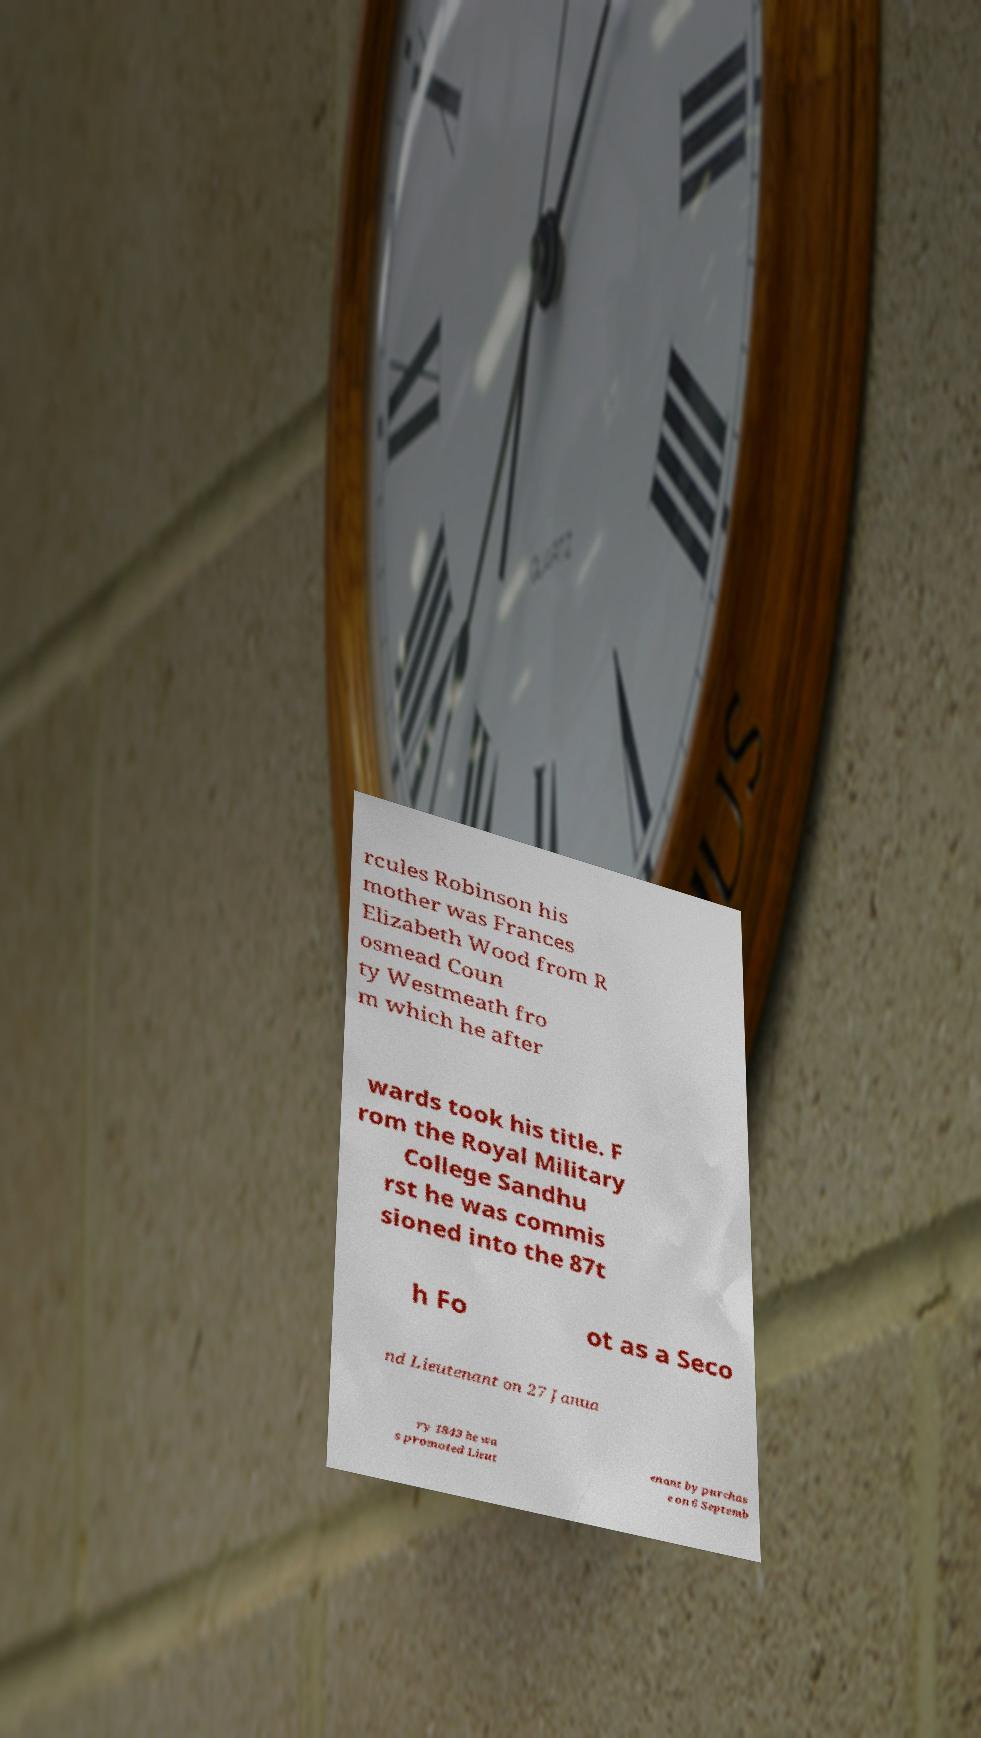Can you accurately transcribe the text from the provided image for me? rcules Robinson his mother was Frances Elizabeth Wood from R osmead Coun ty Westmeath fro m which he after wards took his title. F rom the Royal Military College Sandhu rst he was commis sioned into the 87t h Fo ot as a Seco nd Lieutenant on 27 Janua ry 1843 he wa s promoted Lieut enant by purchas e on 6 Septemb 